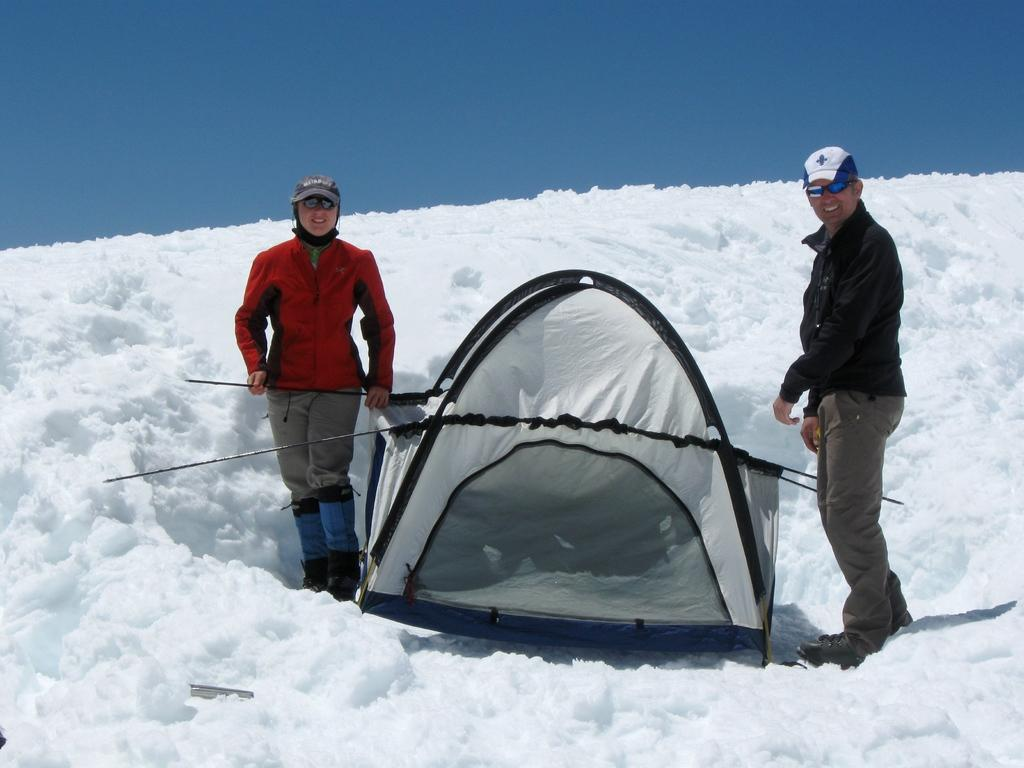How many people are in the image? There are two persons standing on the snow in the image. What structure can be seen in the image? There is a tent in the image. What type of clothing are the persons wearing on their heads? The persons are wearing caps in the image. What type of eyewear are the persons wearing? The persons are wearing shades in the image. What is visible in the background of the image? The sky is visible in the background of the image. What religious symbols can be seen on the persons' clothing in the image? There are no religious symbols visible on the persons' clothing in the image. How do the children feel about the snow in the image? There are no children present in the image, so their feelings cannot be determined. 